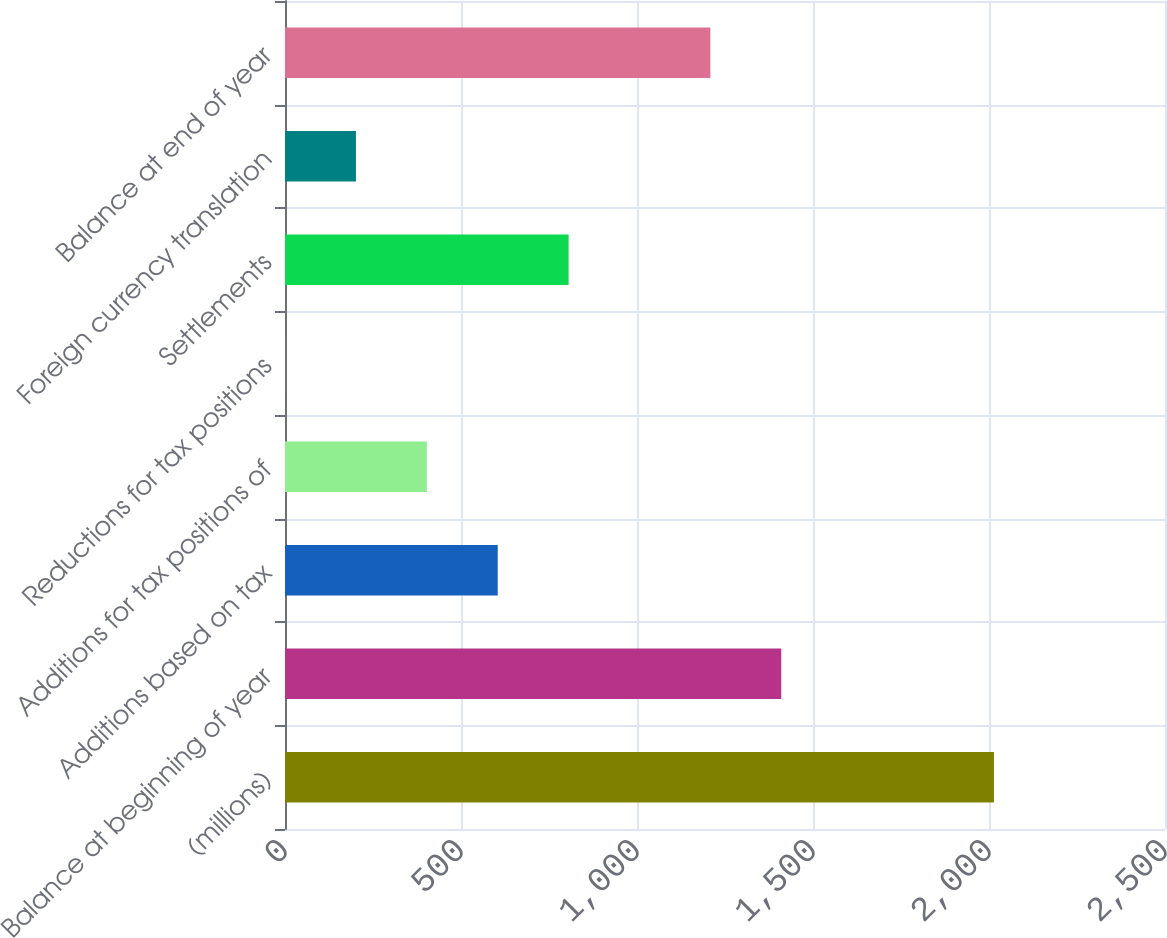<chart> <loc_0><loc_0><loc_500><loc_500><bar_chart><fcel>(millions)<fcel>Balance at beginning of year<fcel>Additions based on tax<fcel>Additions for tax positions of<fcel>Reductions for tax positions<fcel>Settlements<fcel>Foreign currency translation<fcel>Balance at end of year<nl><fcel>2014<fcel>1409.86<fcel>604.34<fcel>402.96<fcel>0.2<fcel>805.72<fcel>201.58<fcel>1208.48<nl></chart> 